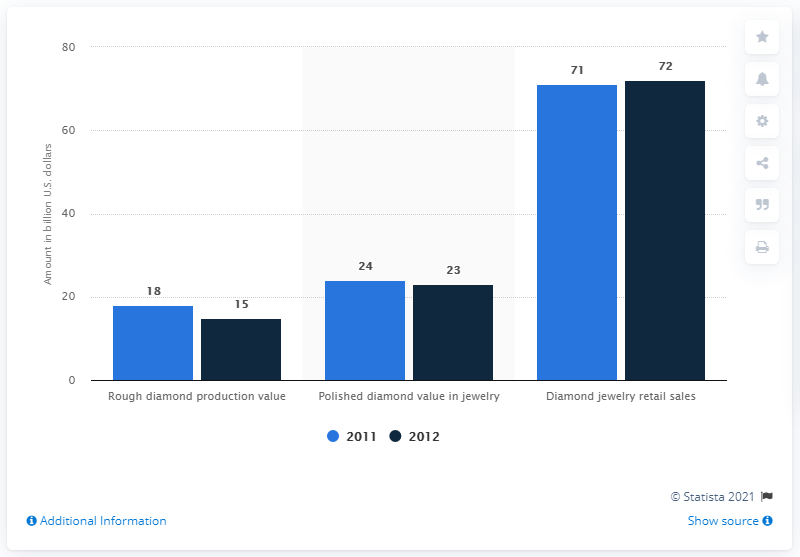Give some essential details in this illustration. The polished diamond value in jewelry showed 24 and 23 for 2011 and 2012 respectively. According to combined 2011 and 2012 data, the ratio of polished diamond value in jewelry to diamond jewelry retail sales is 0.333333333. 